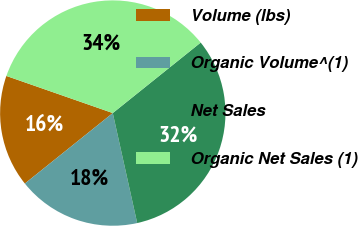Convert chart to OTSL. <chart><loc_0><loc_0><loc_500><loc_500><pie_chart><fcel>Volume (lbs)<fcel>Organic Volume^(1)<fcel>Net Sales<fcel>Organic Net Sales (1)<nl><fcel>16.1%<fcel>17.72%<fcel>32.28%<fcel>33.9%<nl></chart> 